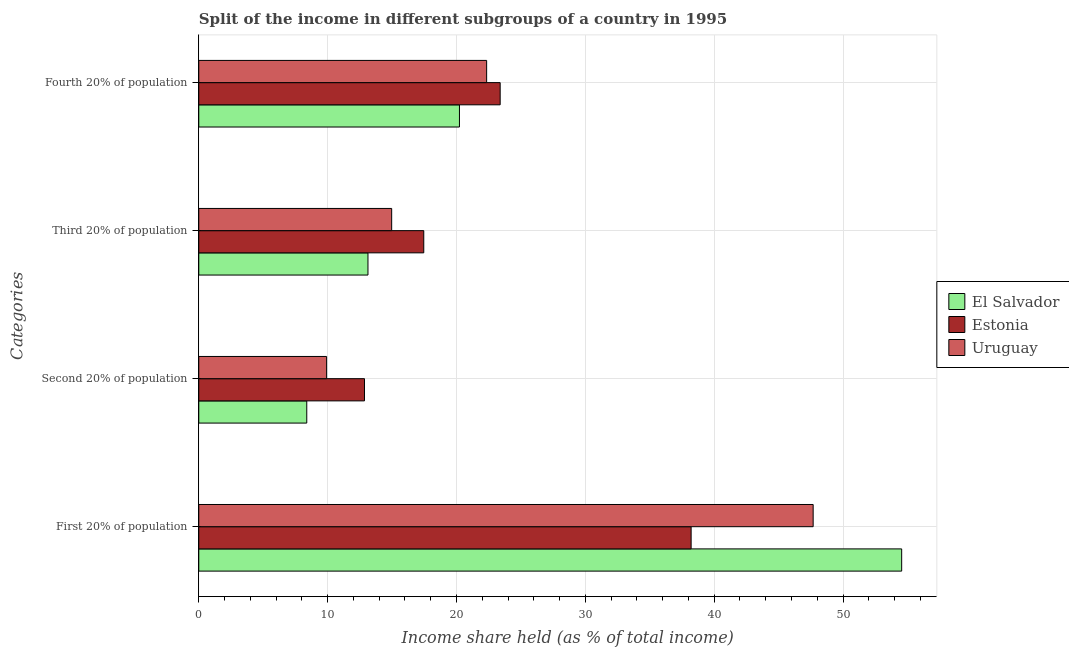Are the number of bars per tick equal to the number of legend labels?
Provide a short and direct response. Yes. Are the number of bars on each tick of the Y-axis equal?
Offer a terse response. Yes. How many bars are there on the 1st tick from the bottom?
Make the answer very short. 3. What is the label of the 2nd group of bars from the top?
Offer a very short reply. Third 20% of population. What is the share of the income held by first 20% of the population in Uruguay?
Make the answer very short. 47.68. Across all countries, what is the maximum share of the income held by third 20% of the population?
Provide a short and direct response. 17.46. Across all countries, what is the minimum share of the income held by first 20% of the population?
Provide a succinct answer. 38.21. In which country was the share of the income held by first 20% of the population maximum?
Keep it short and to the point. El Salvador. In which country was the share of the income held by third 20% of the population minimum?
Keep it short and to the point. El Salvador. What is the total share of the income held by first 20% of the population in the graph?
Offer a terse response. 140.44. What is the difference between the share of the income held by second 20% of the population in Estonia and that in El Salvador?
Your response must be concise. 4.48. What is the difference between the share of the income held by second 20% of the population in Uruguay and the share of the income held by third 20% of the population in El Salvador?
Keep it short and to the point. -3.21. What is the average share of the income held by second 20% of the population per country?
Make the answer very short. 10.39. What is the difference between the share of the income held by fourth 20% of the population and share of the income held by third 20% of the population in Estonia?
Provide a short and direct response. 5.93. In how many countries, is the share of the income held by first 20% of the population greater than 10 %?
Your answer should be compact. 3. What is the ratio of the share of the income held by first 20% of the population in El Salvador to that in Uruguay?
Give a very brief answer. 1.14. Is the share of the income held by fourth 20% of the population in Estonia less than that in El Salvador?
Make the answer very short. No. What is the difference between the highest and the second highest share of the income held by second 20% of the population?
Ensure brevity in your answer.  2.94. What is the difference between the highest and the lowest share of the income held by third 20% of the population?
Keep it short and to the point. 4.33. Is the sum of the share of the income held by second 20% of the population in El Salvador and Uruguay greater than the maximum share of the income held by fourth 20% of the population across all countries?
Your answer should be very brief. No. What does the 1st bar from the top in Second 20% of population represents?
Your answer should be very brief. Uruguay. What does the 2nd bar from the bottom in First 20% of population represents?
Provide a succinct answer. Estonia. Is it the case that in every country, the sum of the share of the income held by first 20% of the population and share of the income held by second 20% of the population is greater than the share of the income held by third 20% of the population?
Give a very brief answer. Yes. How many bars are there?
Your answer should be compact. 12. Are all the bars in the graph horizontal?
Offer a very short reply. Yes. How many countries are there in the graph?
Keep it short and to the point. 3. Does the graph contain any zero values?
Your answer should be very brief. No. Does the graph contain grids?
Provide a succinct answer. Yes. How many legend labels are there?
Make the answer very short. 3. What is the title of the graph?
Keep it short and to the point. Split of the income in different subgroups of a country in 1995. What is the label or title of the X-axis?
Your answer should be very brief. Income share held (as % of total income). What is the label or title of the Y-axis?
Offer a very short reply. Categories. What is the Income share held (as % of total income) in El Salvador in First 20% of population?
Offer a terse response. 54.55. What is the Income share held (as % of total income) of Estonia in First 20% of population?
Your answer should be very brief. 38.21. What is the Income share held (as % of total income) in Uruguay in First 20% of population?
Provide a succinct answer. 47.68. What is the Income share held (as % of total income) of El Salvador in Second 20% of population?
Your answer should be compact. 8.38. What is the Income share held (as % of total income) in Estonia in Second 20% of population?
Offer a terse response. 12.86. What is the Income share held (as % of total income) of Uruguay in Second 20% of population?
Offer a very short reply. 9.92. What is the Income share held (as % of total income) of El Salvador in Third 20% of population?
Your answer should be compact. 13.13. What is the Income share held (as % of total income) in Estonia in Third 20% of population?
Provide a succinct answer. 17.46. What is the Income share held (as % of total income) of Uruguay in Third 20% of population?
Offer a very short reply. 14.97. What is the Income share held (as % of total income) of El Salvador in Fourth 20% of population?
Your answer should be compact. 20.23. What is the Income share held (as % of total income) in Estonia in Fourth 20% of population?
Your answer should be very brief. 23.39. What is the Income share held (as % of total income) in Uruguay in Fourth 20% of population?
Your answer should be compact. 22.34. Across all Categories, what is the maximum Income share held (as % of total income) in El Salvador?
Your answer should be very brief. 54.55. Across all Categories, what is the maximum Income share held (as % of total income) of Estonia?
Keep it short and to the point. 38.21. Across all Categories, what is the maximum Income share held (as % of total income) of Uruguay?
Make the answer very short. 47.68. Across all Categories, what is the minimum Income share held (as % of total income) of El Salvador?
Your response must be concise. 8.38. Across all Categories, what is the minimum Income share held (as % of total income) of Estonia?
Offer a terse response. 12.86. Across all Categories, what is the minimum Income share held (as % of total income) of Uruguay?
Ensure brevity in your answer.  9.92. What is the total Income share held (as % of total income) in El Salvador in the graph?
Provide a short and direct response. 96.29. What is the total Income share held (as % of total income) of Estonia in the graph?
Ensure brevity in your answer.  91.92. What is the total Income share held (as % of total income) of Uruguay in the graph?
Ensure brevity in your answer.  94.91. What is the difference between the Income share held (as % of total income) of El Salvador in First 20% of population and that in Second 20% of population?
Your answer should be very brief. 46.17. What is the difference between the Income share held (as % of total income) in Estonia in First 20% of population and that in Second 20% of population?
Provide a succinct answer. 25.35. What is the difference between the Income share held (as % of total income) of Uruguay in First 20% of population and that in Second 20% of population?
Ensure brevity in your answer.  37.76. What is the difference between the Income share held (as % of total income) of El Salvador in First 20% of population and that in Third 20% of population?
Give a very brief answer. 41.42. What is the difference between the Income share held (as % of total income) of Estonia in First 20% of population and that in Third 20% of population?
Your answer should be compact. 20.75. What is the difference between the Income share held (as % of total income) of Uruguay in First 20% of population and that in Third 20% of population?
Your response must be concise. 32.71. What is the difference between the Income share held (as % of total income) of El Salvador in First 20% of population and that in Fourth 20% of population?
Offer a terse response. 34.32. What is the difference between the Income share held (as % of total income) in Estonia in First 20% of population and that in Fourth 20% of population?
Ensure brevity in your answer.  14.82. What is the difference between the Income share held (as % of total income) in Uruguay in First 20% of population and that in Fourth 20% of population?
Provide a short and direct response. 25.34. What is the difference between the Income share held (as % of total income) of El Salvador in Second 20% of population and that in Third 20% of population?
Make the answer very short. -4.75. What is the difference between the Income share held (as % of total income) of Uruguay in Second 20% of population and that in Third 20% of population?
Provide a succinct answer. -5.05. What is the difference between the Income share held (as % of total income) in El Salvador in Second 20% of population and that in Fourth 20% of population?
Keep it short and to the point. -11.85. What is the difference between the Income share held (as % of total income) in Estonia in Second 20% of population and that in Fourth 20% of population?
Ensure brevity in your answer.  -10.53. What is the difference between the Income share held (as % of total income) of Uruguay in Second 20% of population and that in Fourth 20% of population?
Give a very brief answer. -12.42. What is the difference between the Income share held (as % of total income) in El Salvador in Third 20% of population and that in Fourth 20% of population?
Make the answer very short. -7.1. What is the difference between the Income share held (as % of total income) in Estonia in Third 20% of population and that in Fourth 20% of population?
Provide a succinct answer. -5.93. What is the difference between the Income share held (as % of total income) in Uruguay in Third 20% of population and that in Fourth 20% of population?
Give a very brief answer. -7.37. What is the difference between the Income share held (as % of total income) in El Salvador in First 20% of population and the Income share held (as % of total income) in Estonia in Second 20% of population?
Offer a terse response. 41.69. What is the difference between the Income share held (as % of total income) in El Salvador in First 20% of population and the Income share held (as % of total income) in Uruguay in Second 20% of population?
Your answer should be compact. 44.63. What is the difference between the Income share held (as % of total income) in Estonia in First 20% of population and the Income share held (as % of total income) in Uruguay in Second 20% of population?
Provide a short and direct response. 28.29. What is the difference between the Income share held (as % of total income) in El Salvador in First 20% of population and the Income share held (as % of total income) in Estonia in Third 20% of population?
Offer a terse response. 37.09. What is the difference between the Income share held (as % of total income) of El Salvador in First 20% of population and the Income share held (as % of total income) of Uruguay in Third 20% of population?
Your answer should be compact. 39.58. What is the difference between the Income share held (as % of total income) in Estonia in First 20% of population and the Income share held (as % of total income) in Uruguay in Third 20% of population?
Provide a succinct answer. 23.24. What is the difference between the Income share held (as % of total income) in El Salvador in First 20% of population and the Income share held (as % of total income) in Estonia in Fourth 20% of population?
Offer a terse response. 31.16. What is the difference between the Income share held (as % of total income) in El Salvador in First 20% of population and the Income share held (as % of total income) in Uruguay in Fourth 20% of population?
Make the answer very short. 32.21. What is the difference between the Income share held (as % of total income) in Estonia in First 20% of population and the Income share held (as % of total income) in Uruguay in Fourth 20% of population?
Your answer should be compact. 15.87. What is the difference between the Income share held (as % of total income) of El Salvador in Second 20% of population and the Income share held (as % of total income) of Estonia in Third 20% of population?
Offer a terse response. -9.08. What is the difference between the Income share held (as % of total income) of El Salvador in Second 20% of population and the Income share held (as % of total income) of Uruguay in Third 20% of population?
Your answer should be very brief. -6.59. What is the difference between the Income share held (as % of total income) in Estonia in Second 20% of population and the Income share held (as % of total income) in Uruguay in Third 20% of population?
Your answer should be compact. -2.11. What is the difference between the Income share held (as % of total income) in El Salvador in Second 20% of population and the Income share held (as % of total income) in Estonia in Fourth 20% of population?
Ensure brevity in your answer.  -15.01. What is the difference between the Income share held (as % of total income) in El Salvador in Second 20% of population and the Income share held (as % of total income) in Uruguay in Fourth 20% of population?
Ensure brevity in your answer.  -13.96. What is the difference between the Income share held (as % of total income) of Estonia in Second 20% of population and the Income share held (as % of total income) of Uruguay in Fourth 20% of population?
Provide a short and direct response. -9.48. What is the difference between the Income share held (as % of total income) in El Salvador in Third 20% of population and the Income share held (as % of total income) in Estonia in Fourth 20% of population?
Your answer should be very brief. -10.26. What is the difference between the Income share held (as % of total income) in El Salvador in Third 20% of population and the Income share held (as % of total income) in Uruguay in Fourth 20% of population?
Give a very brief answer. -9.21. What is the difference between the Income share held (as % of total income) of Estonia in Third 20% of population and the Income share held (as % of total income) of Uruguay in Fourth 20% of population?
Offer a terse response. -4.88. What is the average Income share held (as % of total income) in El Salvador per Categories?
Ensure brevity in your answer.  24.07. What is the average Income share held (as % of total income) of Estonia per Categories?
Give a very brief answer. 22.98. What is the average Income share held (as % of total income) in Uruguay per Categories?
Ensure brevity in your answer.  23.73. What is the difference between the Income share held (as % of total income) in El Salvador and Income share held (as % of total income) in Estonia in First 20% of population?
Make the answer very short. 16.34. What is the difference between the Income share held (as % of total income) in El Salvador and Income share held (as % of total income) in Uruguay in First 20% of population?
Provide a succinct answer. 6.87. What is the difference between the Income share held (as % of total income) in Estonia and Income share held (as % of total income) in Uruguay in First 20% of population?
Provide a short and direct response. -9.47. What is the difference between the Income share held (as % of total income) of El Salvador and Income share held (as % of total income) of Estonia in Second 20% of population?
Your answer should be compact. -4.48. What is the difference between the Income share held (as % of total income) of El Salvador and Income share held (as % of total income) of Uruguay in Second 20% of population?
Provide a short and direct response. -1.54. What is the difference between the Income share held (as % of total income) of Estonia and Income share held (as % of total income) of Uruguay in Second 20% of population?
Your answer should be very brief. 2.94. What is the difference between the Income share held (as % of total income) in El Salvador and Income share held (as % of total income) in Estonia in Third 20% of population?
Keep it short and to the point. -4.33. What is the difference between the Income share held (as % of total income) in El Salvador and Income share held (as % of total income) in Uruguay in Third 20% of population?
Offer a very short reply. -1.84. What is the difference between the Income share held (as % of total income) of Estonia and Income share held (as % of total income) of Uruguay in Third 20% of population?
Your answer should be compact. 2.49. What is the difference between the Income share held (as % of total income) of El Salvador and Income share held (as % of total income) of Estonia in Fourth 20% of population?
Offer a very short reply. -3.16. What is the difference between the Income share held (as % of total income) of El Salvador and Income share held (as % of total income) of Uruguay in Fourth 20% of population?
Your answer should be compact. -2.11. What is the difference between the Income share held (as % of total income) in Estonia and Income share held (as % of total income) in Uruguay in Fourth 20% of population?
Provide a short and direct response. 1.05. What is the ratio of the Income share held (as % of total income) in El Salvador in First 20% of population to that in Second 20% of population?
Provide a succinct answer. 6.51. What is the ratio of the Income share held (as % of total income) in Estonia in First 20% of population to that in Second 20% of population?
Offer a very short reply. 2.97. What is the ratio of the Income share held (as % of total income) of Uruguay in First 20% of population to that in Second 20% of population?
Provide a succinct answer. 4.81. What is the ratio of the Income share held (as % of total income) of El Salvador in First 20% of population to that in Third 20% of population?
Your response must be concise. 4.15. What is the ratio of the Income share held (as % of total income) of Estonia in First 20% of population to that in Third 20% of population?
Make the answer very short. 2.19. What is the ratio of the Income share held (as % of total income) of Uruguay in First 20% of population to that in Third 20% of population?
Give a very brief answer. 3.19. What is the ratio of the Income share held (as % of total income) in El Salvador in First 20% of population to that in Fourth 20% of population?
Offer a very short reply. 2.7. What is the ratio of the Income share held (as % of total income) in Estonia in First 20% of population to that in Fourth 20% of population?
Give a very brief answer. 1.63. What is the ratio of the Income share held (as % of total income) in Uruguay in First 20% of population to that in Fourth 20% of population?
Give a very brief answer. 2.13. What is the ratio of the Income share held (as % of total income) of El Salvador in Second 20% of population to that in Third 20% of population?
Keep it short and to the point. 0.64. What is the ratio of the Income share held (as % of total income) of Estonia in Second 20% of population to that in Third 20% of population?
Provide a succinct answer. 0.74. What is the ratio of the Income share held (as % of total income) of Uruguay in Second 20% of population to that in Third 20% of population?
Your response must be concise. 0.66. What is the ratio of the Income share held (as % of total income) of El Salvador in Second 20% of population to that in Fourth 20% of population?
Ensure brevity in your answer.  0.41. What is the ratio of the Income share held (as % of total income) of Estonia in Second 20% of population to that in Fourth 20% of population?
Give a very brief answer. 0.55. What is the ratio of the Income share held (as % of total income) in Uruguay in Second 20% of population to that in Fourth 20% of population?
Offer a very short reply. 0.44. What is the ratio of the Income share held (as % of total income) of El Salvador in Third 20% of population to that in Fourth 20% of population?
Give a very brief answer. 0.65. What is the ratio of the Income share held (as % of total income) in Estonia in Third 20% of population to that in Fourth 20% of population?
Keep it short and to the point. 0.75. What is the ratio of the Income share held (as % of total income) of Uruguay in Third 20% of population to that in Fourth 20% of population?
Provide a short and direct response. 0.67. What is the difference between the highest and the second highest Income share held (as % of total income) of El Salvador?
Offer a very short reply. 34.32. What is the difference between the highest and the second highest Income share held (as % of total income) in Estonia?
Offer a terse response. 14.82. What is the difference between the highest and the second highest Income share held (as % of total income) of Uruguay?
Ensure brevity in your answer.  25.34. What is the difference between the highest and the lowest Income share held (as % of total income) of El Salvador?
Give a very brief answer. 46.17. What is the difference between the highest and the lowest Income share held (as % of total income) of Estonia?
Give a very brief answer. 25.35. What is the difference between the highest and the lowest Income share held (as % of total income) in Uruguay?
Provide a short and direct response. 37.76. 